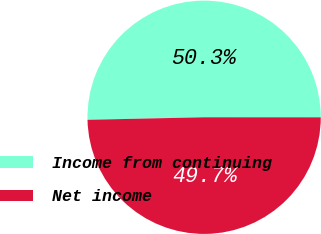Convert chart to OTSL. <chart><loc_0><loc_0><loc_500><loc_500><pie_chart><fcel>Income from continuing<fcel>Net income<nl><fcel>50.35%<fcel>49.65%<nl></chart> 